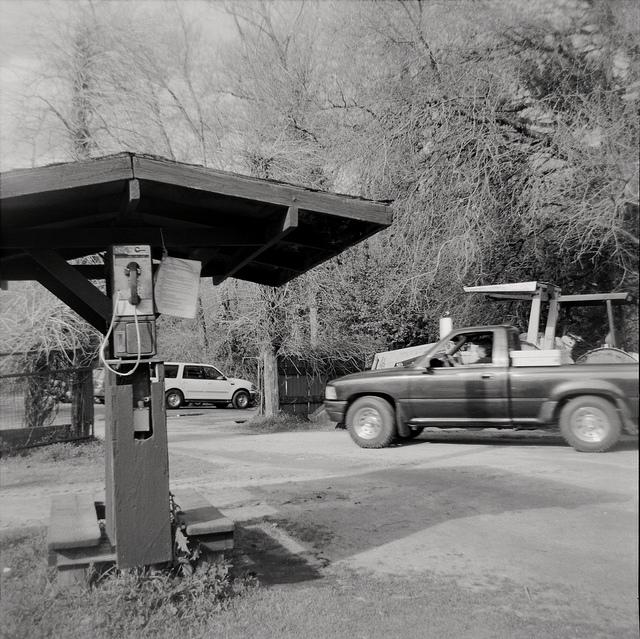Is this the airport?
Write a very short answer. No. Is there a place to sit in this photo?
Concise answer only. Yes. What kind of truck is this?
Be succinct. Pickup. Is there an airplane?
Short answer required. No. Where is the phone?
Quick response, please. Under canopy. Is this indoors?
Be succinct. No. 